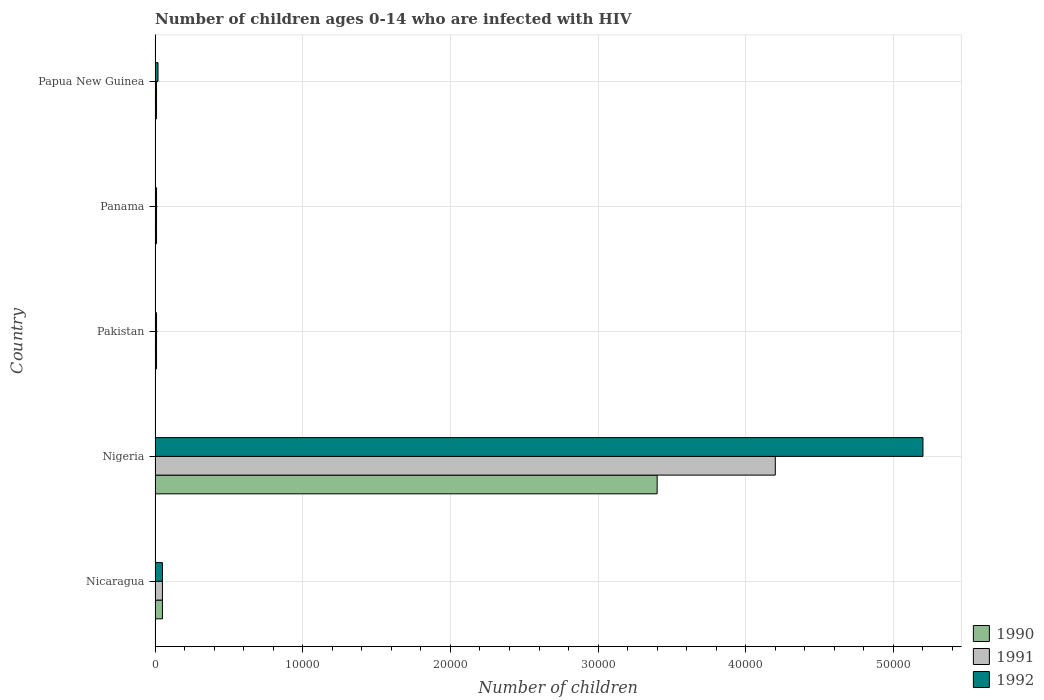How many different coloured bars are there?
Provide a short and direct response. 3. How many groups of bars are there?
Your response must be concise. 5. What is the label of the 3rd group of bars from the top?
Provide a succinct answer. Pakistan. What is the number of HIV infected children in 1991 in Panama?
Provide a succinct answer. 100. Across all countries, what is the maximum number of HIV infected children in 1990?
Offer a very short reply. 3.40e+04. Across all countries, what is the minimum number of HIV infected children in 1990?
Offer a terse response. 100. In which country was the number of HIV infected children in 1992 maximum?
Ensure brevity in your answer.  Nigeria. In which country was the number of HIV infected children in 1992 minimum?
Provide a short and direct response. Pakistan. What is the total number of HIV infected children in 1992 in the graph?
Offer a very short reply. 5.29e+04. What is the difference between the number of HIV infected children in 1991 in Nigeria and that in Pakistan?
Make the answer very short. 4.19e+04. What is the difference between the number of HIV infected children in 1990 in Pakistan and the number of HIV infected children in 1992 in Nigeria?
Your answer should be very brief. -5.19e+04. What is the average number of HIV infected children in 1991 per country?
Provide a short and direct response. 8560. Is the number of HIV infected children in 1991 in Nigeria less than that in Pakistan?
Ensure brevity in your answer.  No. Is the difference between the number of HIV infected children in 1992 in Pakistan and Papua New Guinea greater than the difference between the number of HIV infected children in 1990 in Pakistan and Papua New Guinea?
Your response must be concise. No. What is the difference between the highest and the second highest number of HIV infected children in 1991?
Your answer should be very brief. 4.15e+04. What is the difference between the highest and the lowest number of HIV infected children in 1990?
Make the answer very short. 3.39e+04. In how many countries, is the number of HIV infected children in 1990 greater than the average number of HIV infected children in 1990 taken over all countries?
Offer a terse response. 1. What does the 2nd bar from the top in Pakistan represents?
Your answer should be very brief. 1991. How many countries are there in the graph?
Ensure brevity in your answer.  5. Does the graph contain any zero values?
Offer a terse response. No. Where does the legend appear in the graph?
Keep it short and to the point. Bottom right. How many legend labels are there?
Your answer should be compact. 3. How are the legend labels stacked?
Offer a very short reply. Vertical. What is the title of the graph?
Your answer should be very brief. Number of children ages 0-14 who are infected with HIV. What is the label or title of the X-axis?
Offer a very short reply. Number of children. What is the Number of children of 1992 in Nicaragua?
Make the answer very short. 500. What is the Number of children in 1990 in Nigeria?
Make the answer very short. 3.40e+04. What is the Number of children of 1991 in Nigeria?
Your response must be concise. 4.20e+04. What is the Number of children in 1992 in Nigeria?
Offer a terse response. 5.20e+04. What is the Number of children in 1990 in Pakistan?
Provide a short and direct response. 100. What is the Number of children in 1990 in Panama?
Give a very brief answer. 100. What is the Number of children in 1991 in Panama?
Your answer should be compact. 100. Across all countries, what is the maximum Number of children in 1990?
Provide a short and direct response. 3.40e+04. Across all countries, what is the maximum Number of children of 1991?
Keep it short and to the point. 4.20e+04. Across all countries, what is the maximum Number of children of 1992?
Keep it short and to the point. 5.20e+04. Across all countries, what is the minimum Number of children of 1991?
Offer a very short reply. 100. Across all countries, what is the minimum Number of children in 1992?
Offer a very short reply. 100. What is the total Number of children in 1990 in the graph?
Provide a short and direct response. 3.48e+04. What is the total Number of children in 1991 in the graph?
Provide a succinct answer. 4.28e+04. What is the total Number of children of 1992 in the graph?
Your response must be concise. 5.29e+04. What is the difference between the Number of children of 1990 in Nicaragua and that in Nigeria?
Your response must be concise. -3.35e+04. What is the difference between the Number of children in 1991 in Nicaragua and that in Nigeria?
Offer a very short reply. -4.15e+04. What is the difference between the Number of children in 1992 in Nicaragua and that in Nigeria?
Offer a very short reply. -5.15e+04. What is the difference between the Number of children in 1991 in Nicaragua and that in Pakistan?
Ensure brevity in your answer.  400. What is the difference between the Number of children of 1990 in Nicaragua and that in Panama?
Provide a succinct answer. 400. What is the difference between the Number of children of 1990 in Nicaragua and that in Papua New Guinea?
Give a very brief answer. 400. What is the difference between the Number of children of 1991 in Nicaragua and that in Papua New Guinea?
Give a very brief answer. 400. What is the difference between the Number of children in 1992 in Nicaragua and that in Papua New Guinea?
Provide a short and direct response. 300. What is the difference between the Number of children of 1990 in Nigeria and that in Pakistan?
Your response must be concise. 3.39e+04. What is the difference between the Number of children in 1991 in Nigeria and that in Pakistan?
Provide a short and direct response. 4.19e+04. What is the difference between the Number of children in 1992 in Nigeria and that in Pakistan?
Offer a terse response. 5.19e+04. What is the difference between the Number of children in 1990 in Nigeria and that in Panama?
Your answer should be compact. 3.39e+04. What is the difference between the Number of children of 1991 in Nigeria and that in Panama?
Ensure brevity in your answer.  4.19e+04. What is the difference between the Number of children in 1992 in Nigeria and that in Panama?
Give a very brief answer. 5.19e+04. What is the difference between the Number of children in 1990 in Nigeria and that in Papua New Guinea?
Provide a succinct answer. 3.39e+04. What is the difference between the Number of children in 1991 in Nigeria and that in Papua New Guinea?
Make the answer very short. 4.19e+04. What is the difference between the Number of children in 1992 in Nigeria and that in Papua New Guinea?
Ensure brevity in your answer.  5.18e+04. What is the difference between the Number of children of 1991 in Pakistan and that in Panama?
Offer a very short reply. 0. What is the difference between the Number of children in 1992 in Pakistan and that in Panama?
Give a very brief answer. 0. What is the difference between the Number of children of 1990 in Pakistan and that in Papua New Guinea?
Your response must be concise. 0. What is the difference between the Number of children of 1991 in Pakistan and that in Papua New Guinea?
Your answer should be compact. 0. What is the difference between the Number of children of 1992 in Pakistan and that in Papua New Guinea?
Keep it short and to the point. -100. What is the difference between the Number of children in 1991 in Panama and that in Papua New Guinea?
Provide a short and direct response. 0. What is the difference between the Number of children of 1992 in Panama and that in Papua New Guinea?
Give a very brief answer. -100. What is the difference between the Number of children of 1990 in Nicaragua and the Number of children of 1991 in Nigeria?
Your answer should be compact. -4.15e+04. What is the difference between the Number of children of 1990 in Nicaragua and the Number of children of 1992 in Nigeria?
Your answer should be compact. -5.15e+04. What is the difference between the Number of children in 1991 in Nicaragua and the Number of children in 1992 in Nigeria?
Keep it short and to the point. -5.15e+04. What is the difference between the Number of children in 1990 in Nicaragua and the Number of children in 1991 in Pakistan?
Your answer should be compact. 400. What is the difference between the Number of children in 1990 in Nicaragua and the Number of children in 1991 in Papua New Guinea?
Your response must be concise. 400. What is the difference between the Number of children of 1990 in Nicaragua and the Number of children of 1992 in Papua New Guinea?
Keep it short and to the point. 300. What is the difference between the Number of children of 1991 in Nicaragua and the Number of children of 1992 in Papua New Guinea?
Your answer should be very brief. 300. What is the difference between the Number of children in 1990 in Nigeria and the Number of children in 1991 in Pakistan?
Give a very brief answer. 3.39e+04. What is the difference between the Number of children of 1990 in Nigeria and the Number of children of 1992 in Pakistan?
Your answer should be compact. 3.39e+04. What is the difference between the Number of children in 1991 in Nigeria and the Number of children in 1992 in Pakistan?
Offer a terse response. 4.19e+04. What is the difference between the Number of children of 1990 in Nigeria and the Number of children of 1991 in Panama?
Offer a very short reply. 3.39e+04. What is the difference between the Number of children in 1990 in Nigeria and the Number of children in 1992 in Panama?
Offer a terse response. 3.39e+04. What is the difference between the Number of children of 1991 in Nigeria and the Number of children of 1992 in Panama?
Offer a very short reply. 4.19e+04. What is the difference between the Number of children of 1990 in Nigeria and the Number of children of 1991 in Papua New Guinea?
Your answer should be very brief. 3.39e+04. What is the difference between the Number of children in 1990 in Nigeria and the Number of children in 1992 in Papua New Guinea?
Your answer should be compact. 3.38e+04. What is the difference between the Number of children of 1991 in Nigeria and the Number of children of 1992 in Papua New Guinea?
Ensure brevity in your answer.  4.18e+04. What is the difference between the Number of children in 1991 in Pakistan and the Number of children in 1992 in Panama?
Your answer should be very brief. 0. What is the difference between the Number of children of 1990 in Pakistan and the Number of children of 1991 in Papua New Guinea?
Your answer should be very brief. 0. What is the difference between the Number of children in 1990 in Pakistan and the Number of children in 1992 in Papua New Guinea?
Offer a terse response. -100. What is the difference between the Number of children of 1991 in Pakistan and the Number of children of 1992 in Papua New Guinea?
Provide a short and direct response. -100. What is the difference between the Number of children of 1990 in Panama and the Number of children of 1991 in Papua New Guinea?
Offer a terse response. 0. What is the difference between the Number of children in 1990 in Panama and the Number of children in 1992 in Papua New Guinea?
Your response must be concise. -100. What is the difference between the Number of children of 1991 in Panama and the Number of children of 1992 in Papua New Guinea?
Offer a terse response. -100. What is the average Number of children in 1990 per country?
Make the answer very short. 6960. What is the average Number of children in 1991 per country?
Keep it short and to the point. 8560. What is the average Number of children of 1992 per country?
Your response must be concise. 1.06e+04. What is the difference between the Number of children in 1990 and Number of children in 1991 in Nigeria?
Give a very brief answer. -8000. What is the difference between the Number of children in 1990 and Number of children in 1992 in Nigeria?
Make the answer very short. -1.80e+04. What is the difference between the Number of children in 1990 and Number of children in 1991 in Pakistan?
Keep it short and to the point. 0. What is the difference between the Number of children in 1990 and Number of children in 1992 in Panama?
Give a very brief answer. 0. What is the difference between the Number of children of 1991 and Number of children of 1992 in Panama?
Your response must be concise. 0. What is the difference between the Number of children in 1990 and Number of children in 1991 in Papua New Guinea?
Offer a very short reply. 0. What is the difference between the Number of children in 1990 and Number of children in 1992 in Papua New Guinea?
Your answer should be compact. -100. What is the difference between the Number of children in 1991 and Number of children in 1992 in Papua New Guinea?
Ensure brevity in your answer.  -100. What is the ratio of the Number of children in 1990 in Nicaragua to that in Nigeria?
Give a very brief answer. 0.01. What is the ratio of the Number of children in 1991 in Nicaragua to that in Nigeria?
Your answer should be very brief. 0.01. What is the ratio of the Number of children of 1992 in Nicaragua to that in Nigeria?
Give a very brief answer. 0.01. What is the ratio of the Number of children of 1990 in Nicaragua to that in Pakistan?
Offer a terse response. 5. What is the ratio of the Number of children of 1992 in Nicaragua to that in Pakistan?
Give a very brief answer. 5. What is the ratio of the Number of children of 1991 in Nicaragua to that in Panama?
Your response must be concise. 5. What is the ratio of the Number of children in 1992 in Nicaragua to that in Panama?
Keep it short and to the point. 5. What is the ratio of the Number of children in 1990 in Nicaragua to that in Papua New Guinea?
Make the answer very short. 5. What is the ratio of the Number of children of 1991 in Nicaragua to that in Papua New Guinea?
Your response must be concise. 5. What is the ratio of the Number of children of 1990 in Nigeria to that in Pakistan?
Your answer should be very brief. 340. What is the ratio of the Number of children of 1991 in Nigeria to that in Pakistan?
Provide a short and direct response. 420. What is the ratio of the Number of children of 1992 in Nigeria to that in Pakistan?
Your answer should be very brief. 520. What is the ratio of the Number of children of 1990 in Nigeria to that in Panama?
Your response must be concise. 340. What is the ratio of the Number of children in 1991 in Nigeria to that in Panama?
Your answer should be very brief. 420. What is the ratio of the Number of children of 1992 in Nigeria to that in Panama?
Make the answer very short. 520. What is the ratio of the Number of children in 1990 in Nigeria to that in Papua New Guinea?
Offer a very short reply. 340. What is the ratio of the Number of children of 1991 in Nigeria to that in Papua New Guinea?
Offer a terse response. 420. What is the ratio of the Number of children of 1992 in Nigeria to that in Papua New Guinea?
Keep it short and to the point. 260. What is the ratio of the Number of children of 1990 in Pakistan to that in Panama?
Your response must be concise. 1. What is the ratio of the Number of children of 1991 in Pakistan to that in Panama?
Your answer should be very brief. 1. What is the ratio of the Number of children of 1990 in Pakistan to that in Papua New Guinea?
Make the answer very short. 1. What is the ratio of the Number of children of 1991 in Pakistan to that in Papua New Guinea?
Give a very brief answer. 1. What is the ratio of the Number of children in 1992 in Pakistan to that in Papua New Guinea?
Provide a short and direct response. 0.5. What is the ratio of the Number of children in 1991 in Panama to that in Papua New Guinea?
Your response must be concise. 1. What is the ratio of the Number of children of 1992 in Panama to that in Papua New Guinea?
Offer a very short reply. 0.5. What is the difference between the highest and the second highest Number of children in 1990?
Offer a very short reply. 3.35e+04. What is the difference between the highest and the second highest Number of children in 1991?
Give a very brief answer. 4.15e+04. What is the difference between the highest and the second highest Number of children of 1992?
Offer a terse response. 5.15e+04. What is the difference between the highest and the lowest Number of children in 1990?
Your answer should be compact. 3.39e+04. What is the difference between the highest and the lowest Number of children in 1991?
Provide a short and direct response. 4.19e+04. What is the difference between the highest and the lowest Number of children in 1992?
Keep it short and to the point. 5.19e+04. 